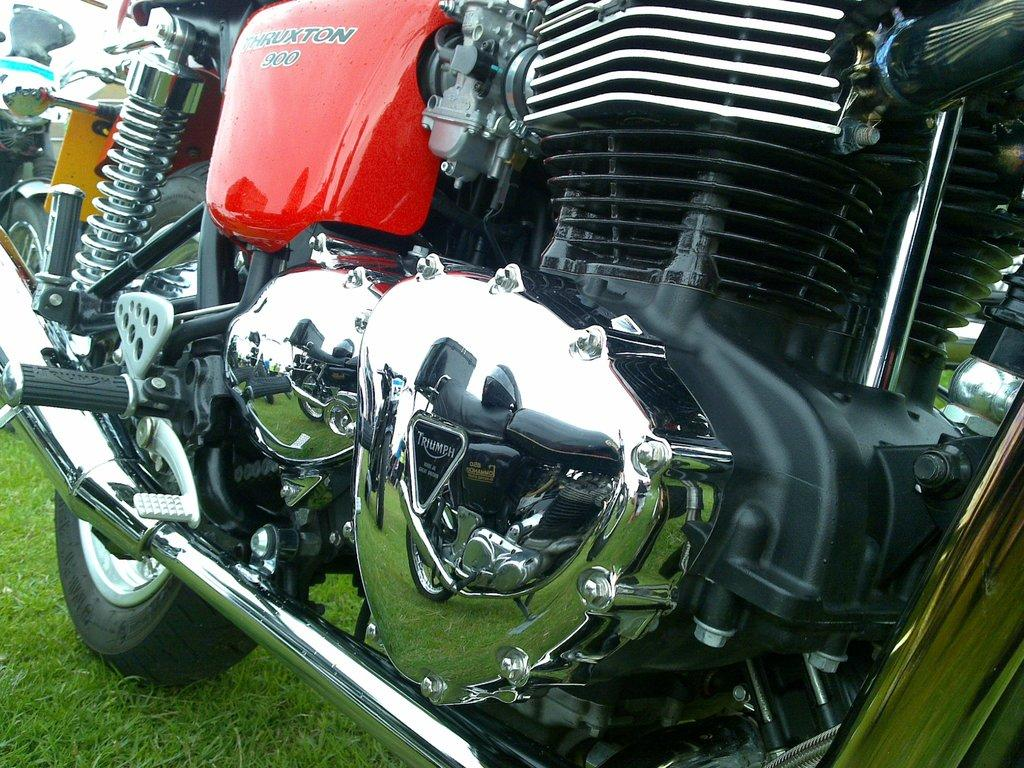What is the main subject in the center of the image? There is a bike in the center of the image. Where is the bike located? The bike is on a grassland. Are there any other bikes visible in the image? Yes, there appears to be another bike on the left side of the image. Can you tell me how many mice are hiding under the bike in the image? There are no mice present in the image; it features bikes on a grassland. Is there a library visible in the background of the image? There is no library present in the image; it only features bikes on a grassland. 